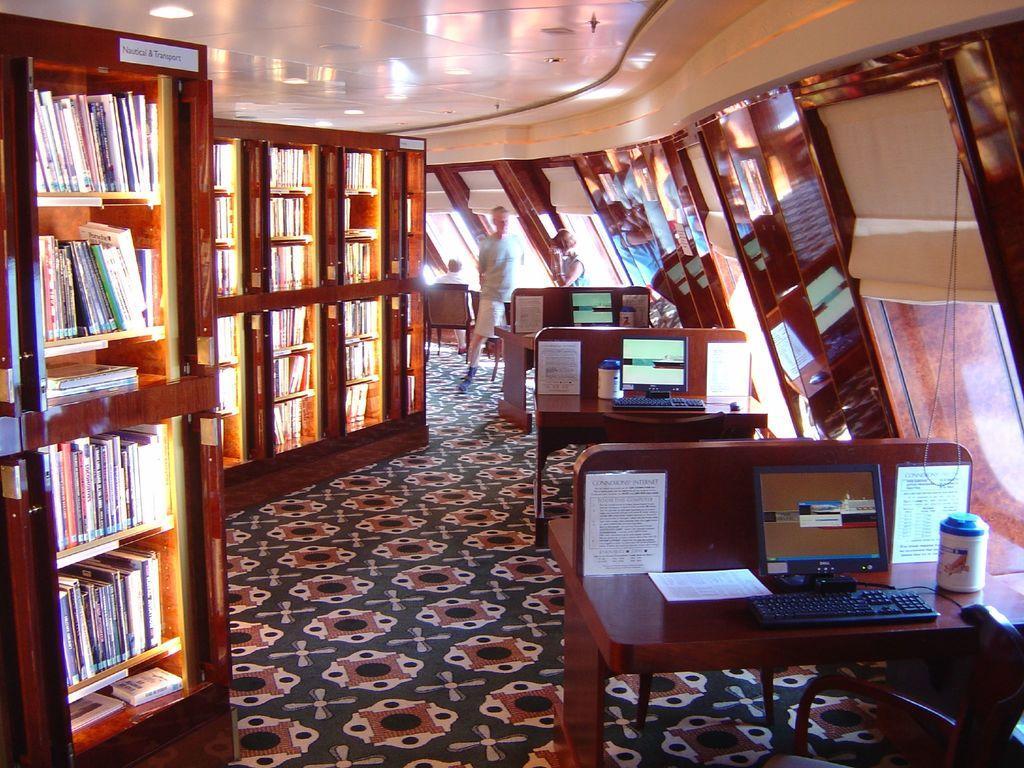In one or two sentences, can you explain what this image depicts? In this image i can see there are few desks on which we have few computers on it. I can there is a cupboard with few books in it. 